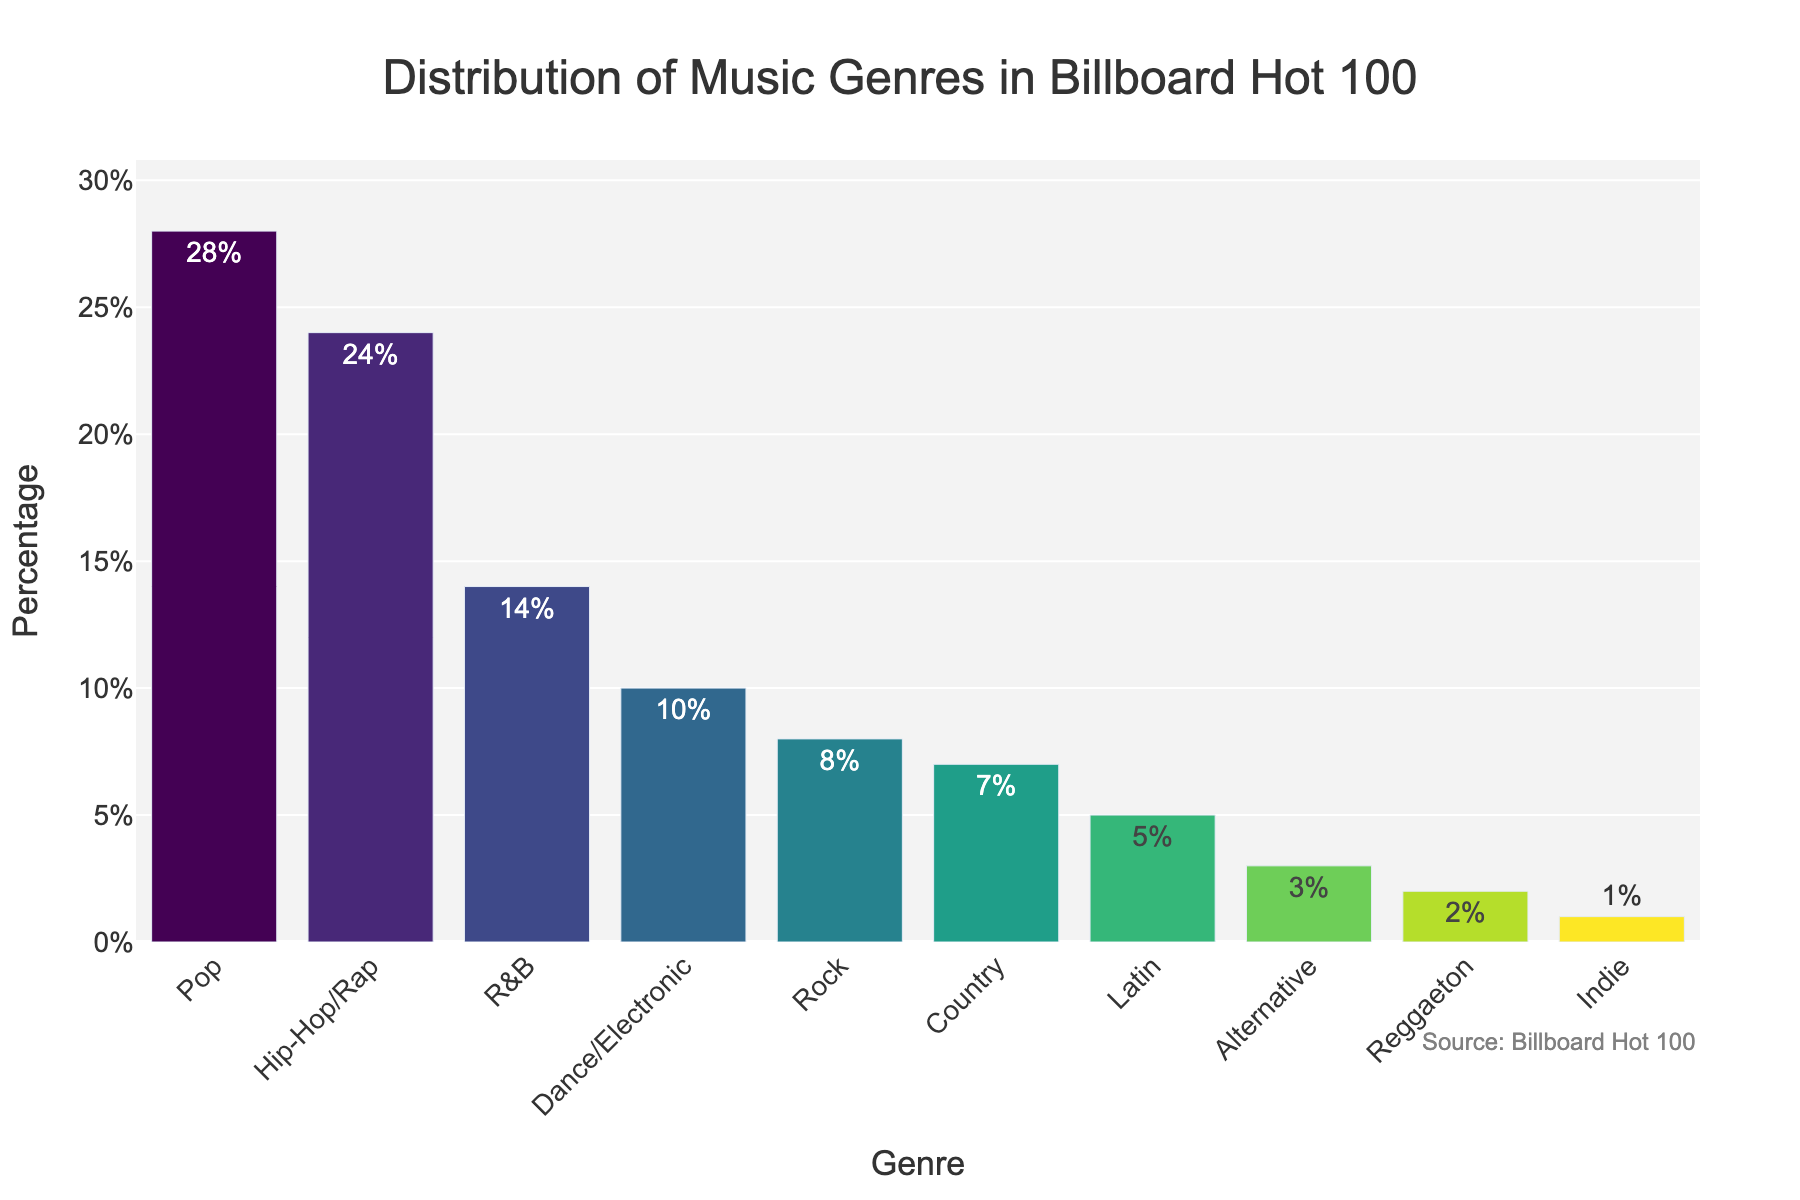Which genre has the highest percentage in the Billboard Hot 100? By looking at the height of the bars, Pop has the highest value.
Answer: Pop Which genre has a smaller percentage, Rock or Country? By comparing the heights of the bars, the Rock bar is slightly higher than the Country bar.
Answer: Country How many genres have a percentage of 10% or higher? Count the genres with percentages 28%, 24%, 14%, and 10%.
Answer: 4 What is the total percentage for Latin and Alternative genres combined? Add the percentages for Latin (5%) and Alternative (3%): 5% + 3% = 8%.
Answer: 8% Which genre has a percentage of 1%? By looking at the labels, Indie has a percentage of 1%.
Answer: Indie Are there more genres in the 2%-5% range or in the 7%-10% range? There are three genres (Latin, Alternative, Reggaeton) in the 2%-5% range and two genres (Dance/Electronic, Country) in the 7%-10% range.
Answer: 2%-5% range Which two genres have a combined percentage that is closest to that of Hip-Hop/Rap? By adding percentages: Rock (8%) + Country (7%) = 15%, closest value to 24% (Hip-Hop/Rap).
Answer: Rock and Country What's the difference in percentage points between Pop and Dance/Electronic genres? Subtract the percentage for Dance/Electronic (10%) from the percentage for Pop (28%): 28%-10% = 18%.
Answer: 18% What percentage is represented by genres not including Pop and Hip-Hop/Rap? Subtract the percentages for Pop (28%) and Hip-Hop/Rap (24%) from 100%: 100%-28%-24%=48%.
Answer: 48% Between R&B and Indie genres, which one has the higher percentage and by how much? R&B has a percentage of 14% and Indie has 1%, so 14%-1%=13%.
Answer: R&B by 13% 